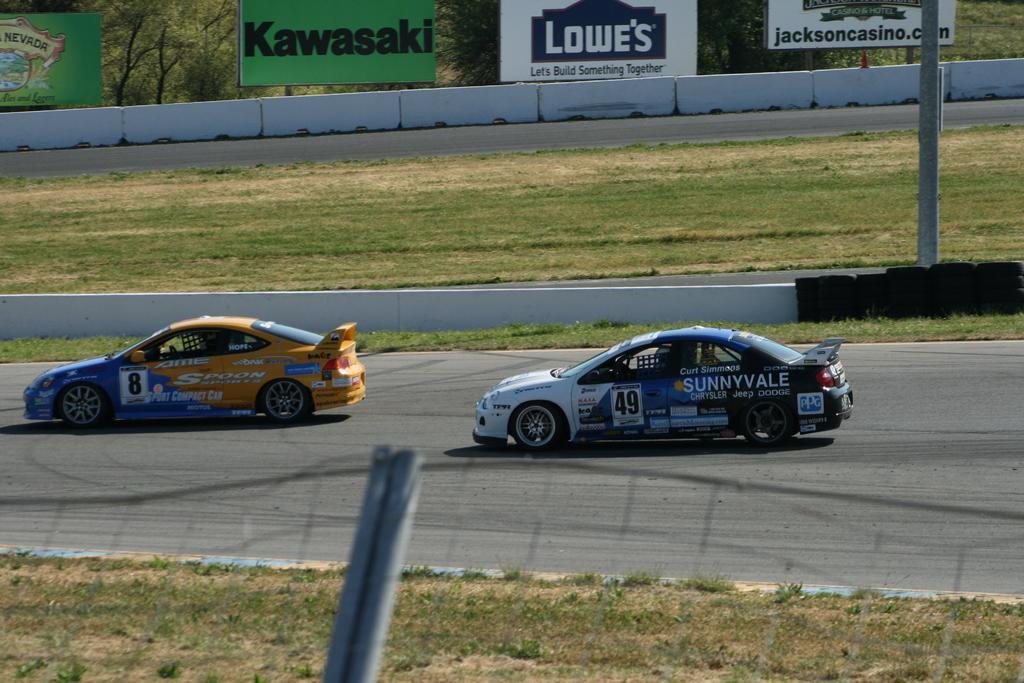Can you describe this image briefly? In this image we can see two cars are passing on the road. On the either sides of the road there is a grass. In the background of the image there are banners and trees. 